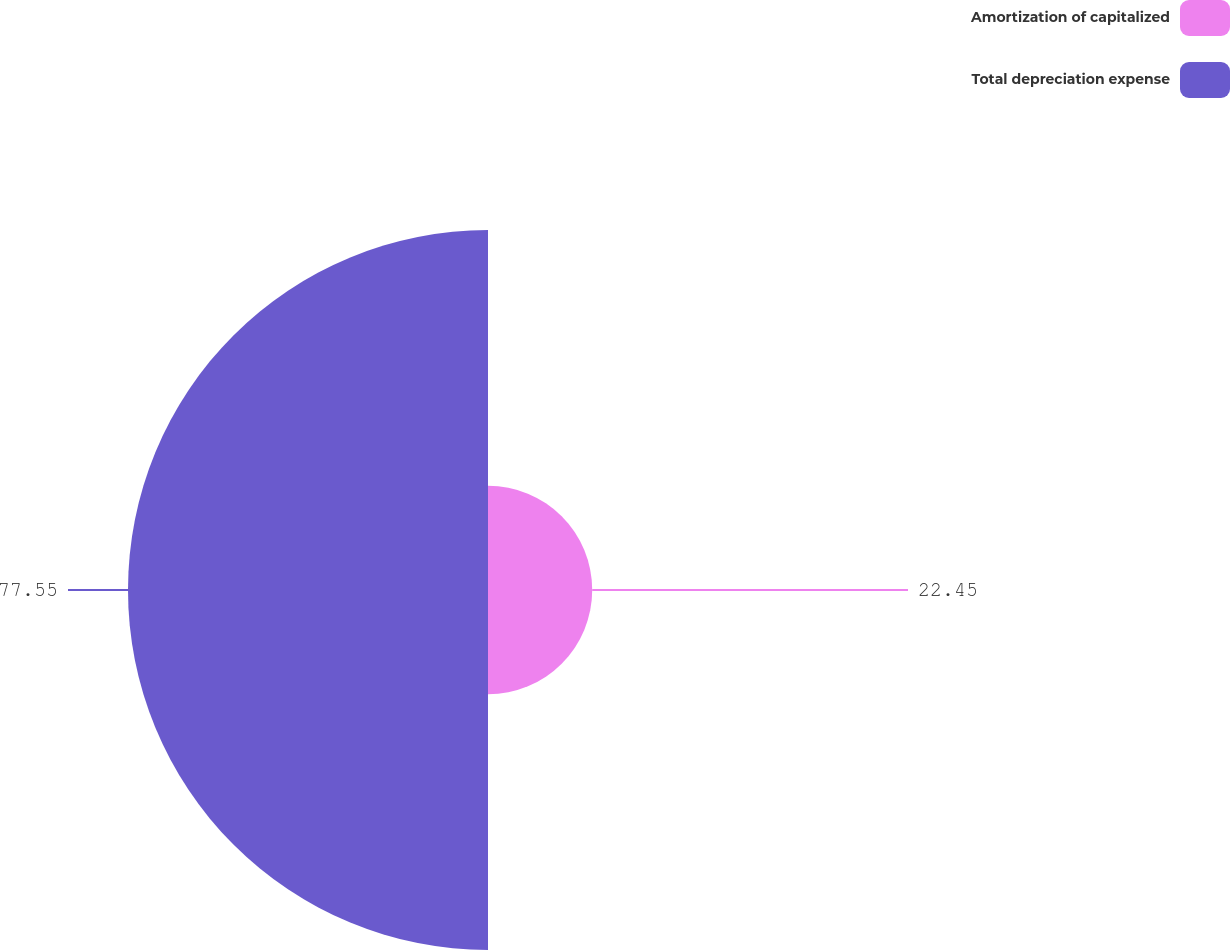Convert chart. <chart><loc_0><loc_0><loc_500><loc_500><pie_chart><fcel>Amortization of capitalized<fcel>Total depreciation expense<nl><fcel>22.45%<fcel>77.55%<nl></chart> 